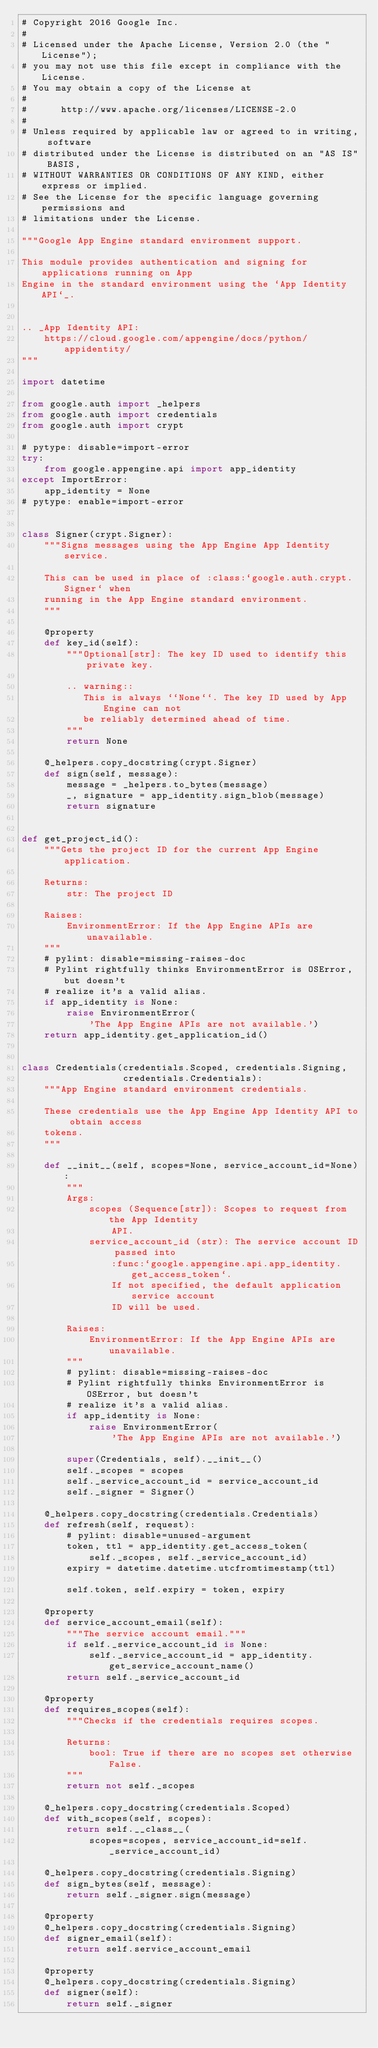Convert code to text. <code><loc_0><loc_0><loc_500><loc_500><_Python_># Copyright 2016 Google Inc.
#
# Licensed under the Apache License, Version 2.0 (the "License");
# you may not use this file except in compliance with the License.
# You may obtain a copy of the License at
#
#      http://www.apache.org/licenses/LICENSE-2.0
#
# Unless required by applicable law or agreed to in writing, software
# distributed under the License is distributed on an "AS IS" BASIS,
# WITHOUT WARRANTIES OR CONDITIONS OF ANY KIND, either express or implied.
# See the License for the specific language governing permissions and
# limitations under the License.

"""Google App Engine standard environment support.

This module provides authentication and signing for applications running on App
Engine in the standard environment using the `App Identity API`_.


.. _App Identity API:
    https://cloud.google.com/appengine/docs/python/appidentity/
"""

import datetime

from google.auth import _helpers
from google.auth import credentials
from google.auth import crypt

# pytype: disable=import-error
try:
    from google.appengine.api import app_identity
except ImportError:
    app_identity = None
# pytype: enable=import-error


class Signer(crypt.Signer):
    """Signs messages using the App Engine App Identity service.

    This can be used in place of :class:`google.auth.crypt.Signer` when
    running in the App Engine standard environment.
    """

    @property
    def key_id(self):
        """Optional[str]: The key ID used to identify this private key.

        .. warning::
           This is always ``None``. The key ID used by App Engine can not
           be reliably determined ahead of time.
        """
        return None

    @_helpers.copy_docstring(crypt.Signer)
    def sign(self, message):
        message = _helpers.to_bytes(message)
        _, signature = app_identity.sign_blob(message)
        return signature


def get_project_id():
    """Gets the project ID for the current App Engine application.

    Returns:
        str: The project ID

    Raises:
        EnvironmentError: If the App Engine APIs are unavailable.
    """
    # pylint: disable=missing-raises-doc
    # Pylint rightfully thinks EnvironmentError is OSError, but doesn't
    # realize it's a valid alias.
    if app_identity is None:
        raise EnvironmentError(
            'The App Engine APIs are not available.')
    return app_identity.get_application_id()


class Credentials(credentials.Scoped, credentials.Signing,
                  credentials.Credentials):
    """App Engine standard environment credentials.

    These credentials use the App Engine App Identity API to obtain access
    tokens.
    """

    def __init__(self, scopes=None, service_account_id=None):
        """
        Args:
            scopes (Sequence[str]): Scopes to request from the App Identity
                API.
            service_account_id (str): The service account ID passed into
                :func:`google.appengine.api.app_identity.get_access_token`.
                If not specified, the default application service account
                ID will be used.

        Raises:
            EnvironmentError: If the App Engine APIs are unavailable.
        """
        # pylint: disable=missing-raises-doc
        # Pylint rightfully thinks EnvironmentError is OSError, but doesn't
        # realize it's a valid alias.
        if app_identity is None:
            raise EnvironmentError(
                'The App Engine APIs are not available.')

        super(Credentials, self).__init__()
        self._scopes = scopes
        self._service_account_id = service_account_id
        self._signer = Signer()

    @_helpers.copy_docstring(credentials.Credentials)
    def refresh(self, request):
        # pylint: disable=unused-argument
        token, ttl = app_identity.get_access_token(
            self._scopes, self._service_account_id)
        expiry = datetime.datetime.utcfromtimestamp(ttl)

        self.token, self.expiry = token, expiry

    @property
    def service_account_email(self):
        """The service account email."""
        if self._service_account_id is None:
            self._service_account_id = app_identity.get_service_account_name()
        return self._service_account_id

    @property
    def requires_scopes(self):
        """Checks if the credentials requires scopes.

        Returns:
            bool: True if there are no scopes set otherwise False.
        """
        return not self._scopes

    @_helpers.copy_docstring(credentials.Scoped)
    def with_scopes(self, scopes):
        return self.__class__(
            scopes=scopes, service_account_id=self._service_account_id)

    @_helpers.copy_docstring(credentials.Signing)
    def sign_bytes(self, message):
        return self._signer.sign(message)

    @property
    @_helpers.copy_docstring(credentials.Signing)
    def signer_email(self):
        return self.service_account_email

    @property
    @_helpers.copy_docstring(credentials.Signing)
    def signer(self):
        return self._signer
</code> 